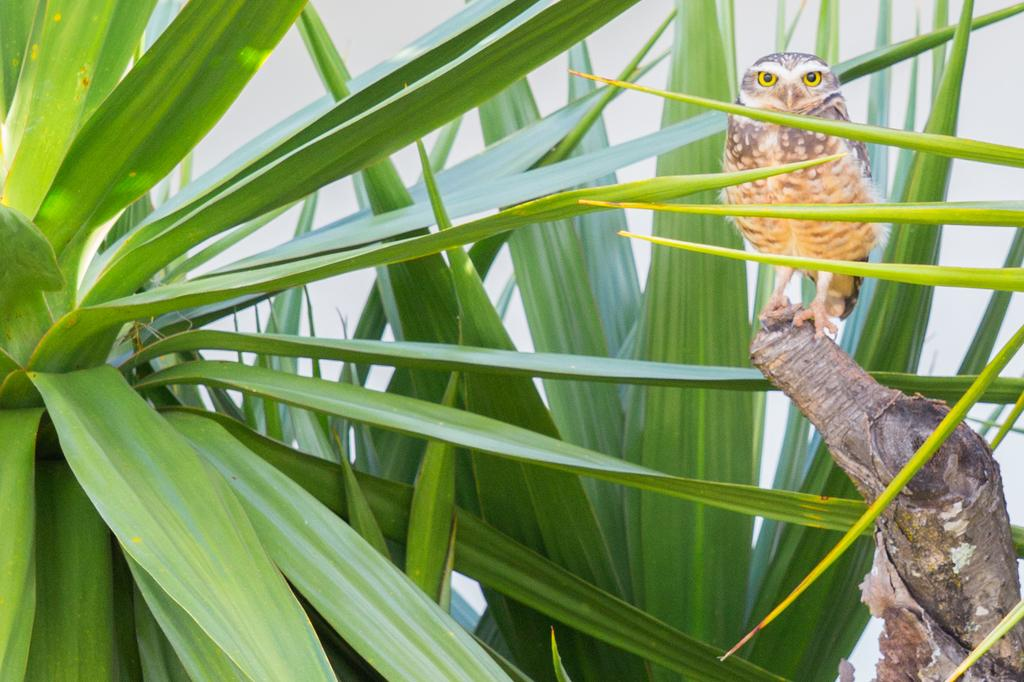What animal is sitting on the tree stump in the image? There is an owl on a tree stump in the image. What type of vegetation is present on the ground in the image? There are plants on the ground in the image. What color is the background of the image? The background of the image is white. What type of chain is hanging from the owl's neck in the image? There is no chain present in the image; the owl is not wearing any accessories. 